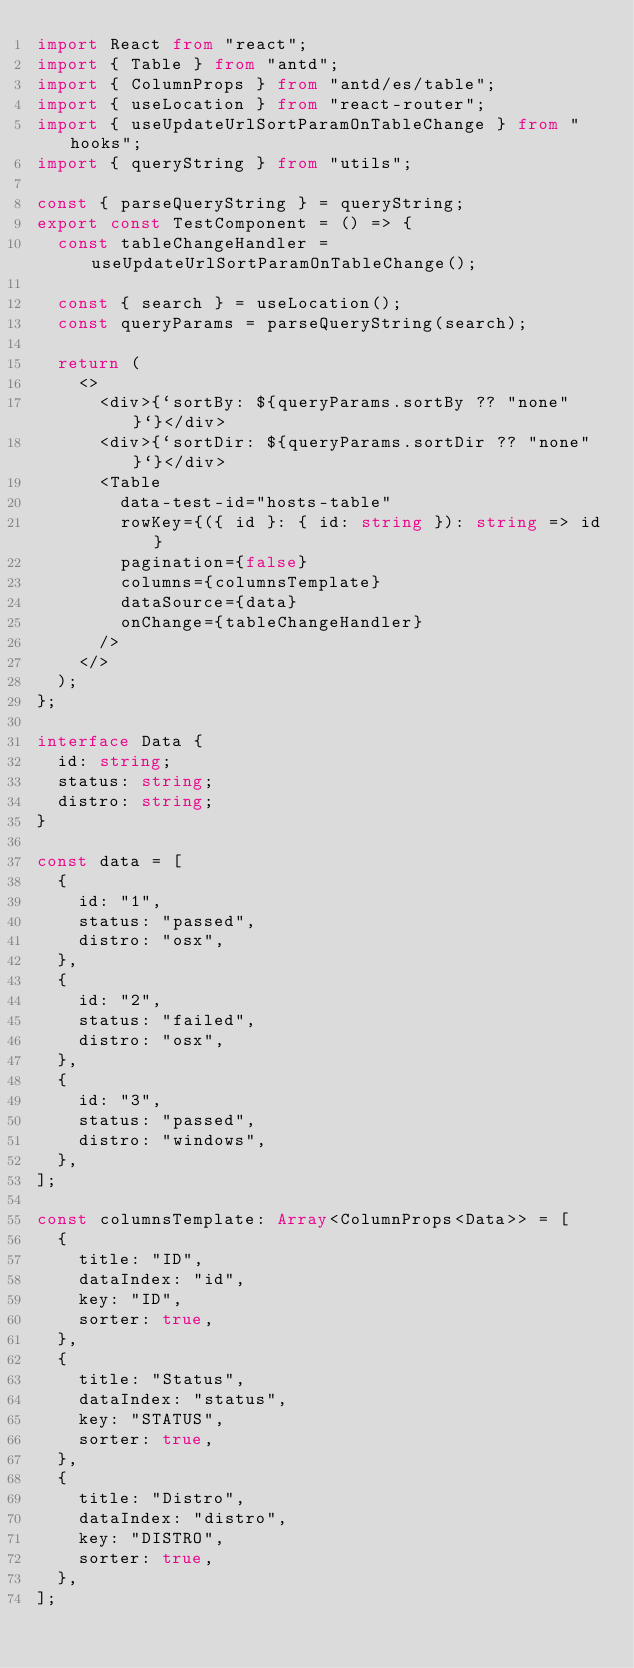Convert code to text. <code><loc_0><loc_0><loc_500><loc_500><_TypeScript_>import React from "react";
import { Table } from "antd";
import { ColumnProps } from "antd/es/table";
import { useLocation } from "react-router";
import { useUpdateUrlSortParamOnTableChange } from "hooks";
import { queryString } from "utils";

const { parseQueryString } = queryString;
export const TestComponent = () => {
  const tableChangeHandler = useUpdateUrlSortParamOnTableChange();

  const { search } = useLocation();
  const queryParams = parseQueryString(search);

  return (
    <>
      <div>{`sortBy: ${queryParams.sortBy ?? "none"}`}</div>
      <div>{`sortDir: ${queryParams.sortDir ?? "none"}`}</div>
      <Table
        data-test-id="hosts-table"
        rowKey={({ id }: { id: string }): string => id}
        pagination={false}
        columns={columnsTemplate}
        dataSource={data}
        onChange={tableChangeHandler}
      />
    </>
  );
};

interface Data {
  id: string;
  status: string;
  distro: string;
}

const data = [
  {
    id: "1",
    status: "passed",
    distro: "osx",
  },
  {
    id: "2",
    status: "failed",
    distro: "osx",
  },
  {
    id: "3",
    status: "passed",
    distro: "windows",
  },
];

const columnsTemplate: Array<ColumnProps<Data>> = [
  {
    title: "ID",
    dataIndex: "id",
    key: "ID",
    sorter: true,
  },
  {
    title: "Status",
    dataIndex: "status",
    key: "STATUS",
    sorter: true,
  },
  {
    title: "Distro",
    dataIndex: "distro",
    key: "DISTRO",
    sorter: true,
  },
];
</code> 